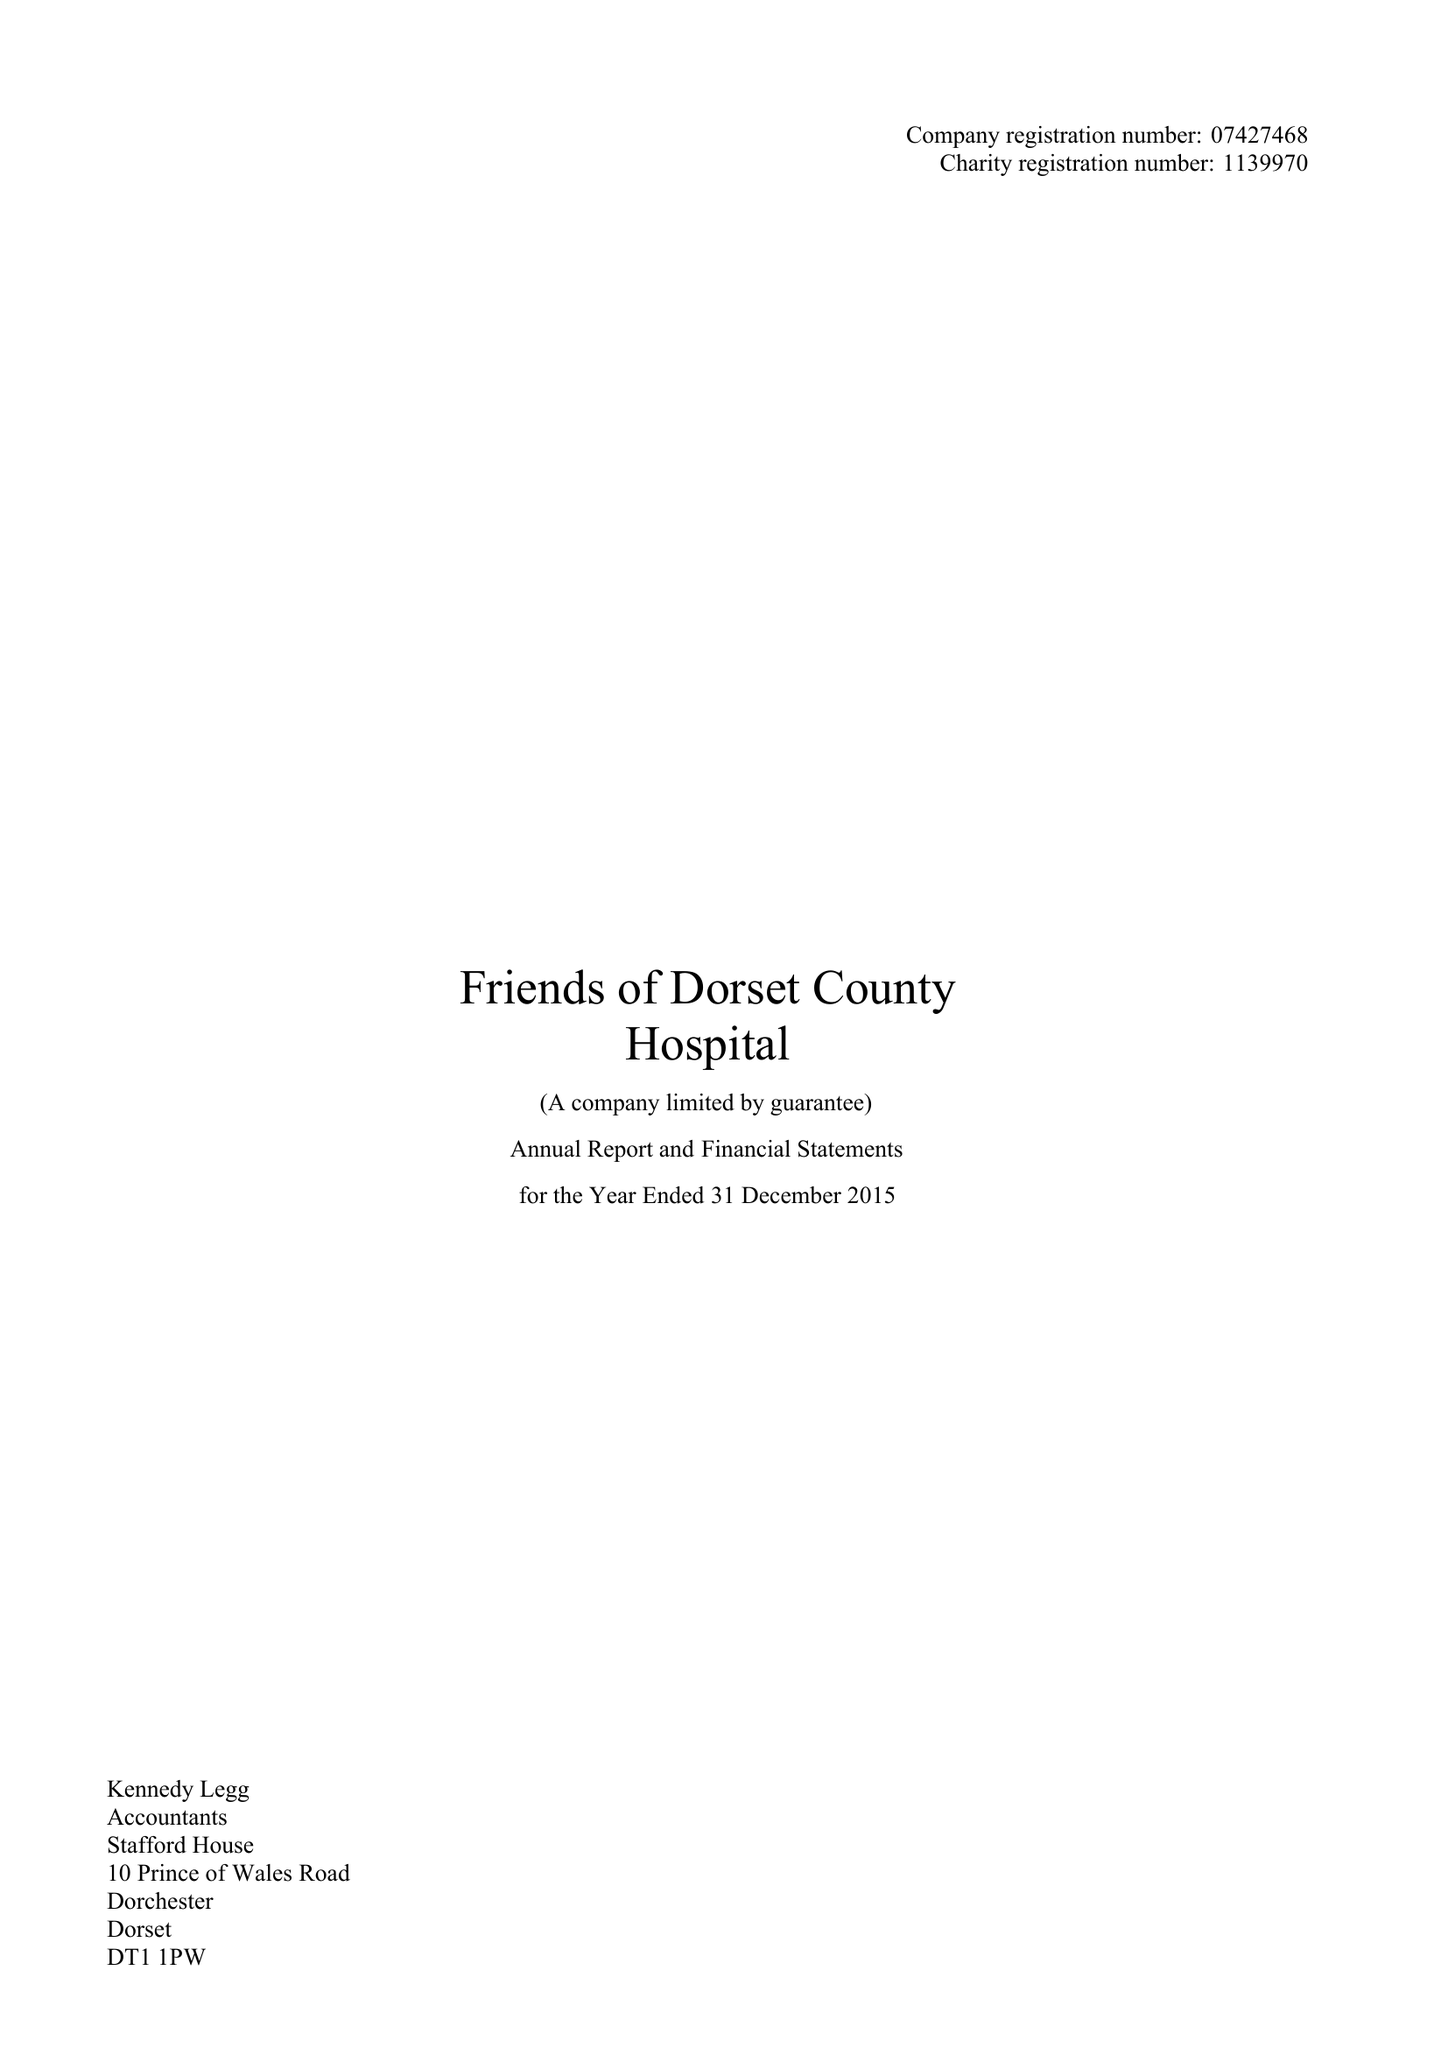What is the value for the income_annually_in_british_pounds?
Answer the question using a single word or phrase. 234555.00 